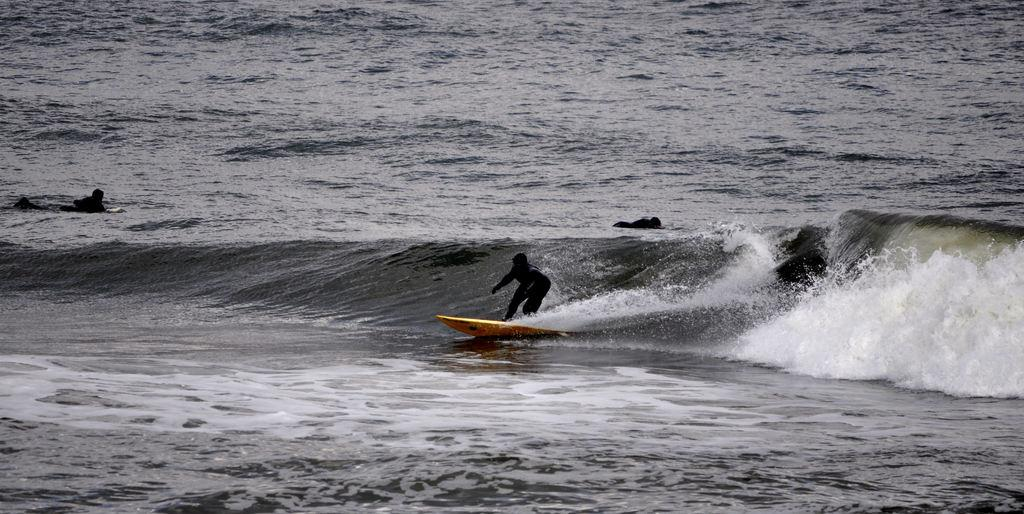What is the person in the image doing? The person is surfing on water. What tool is the person using to surf? The person is using a surfboard. What color is the surfboard? The surfboard is yellow. How many fingers can be seen on the person's hand while surfing? There is no visible hand or fingers on the person in the image, as they are focused on surfing. 